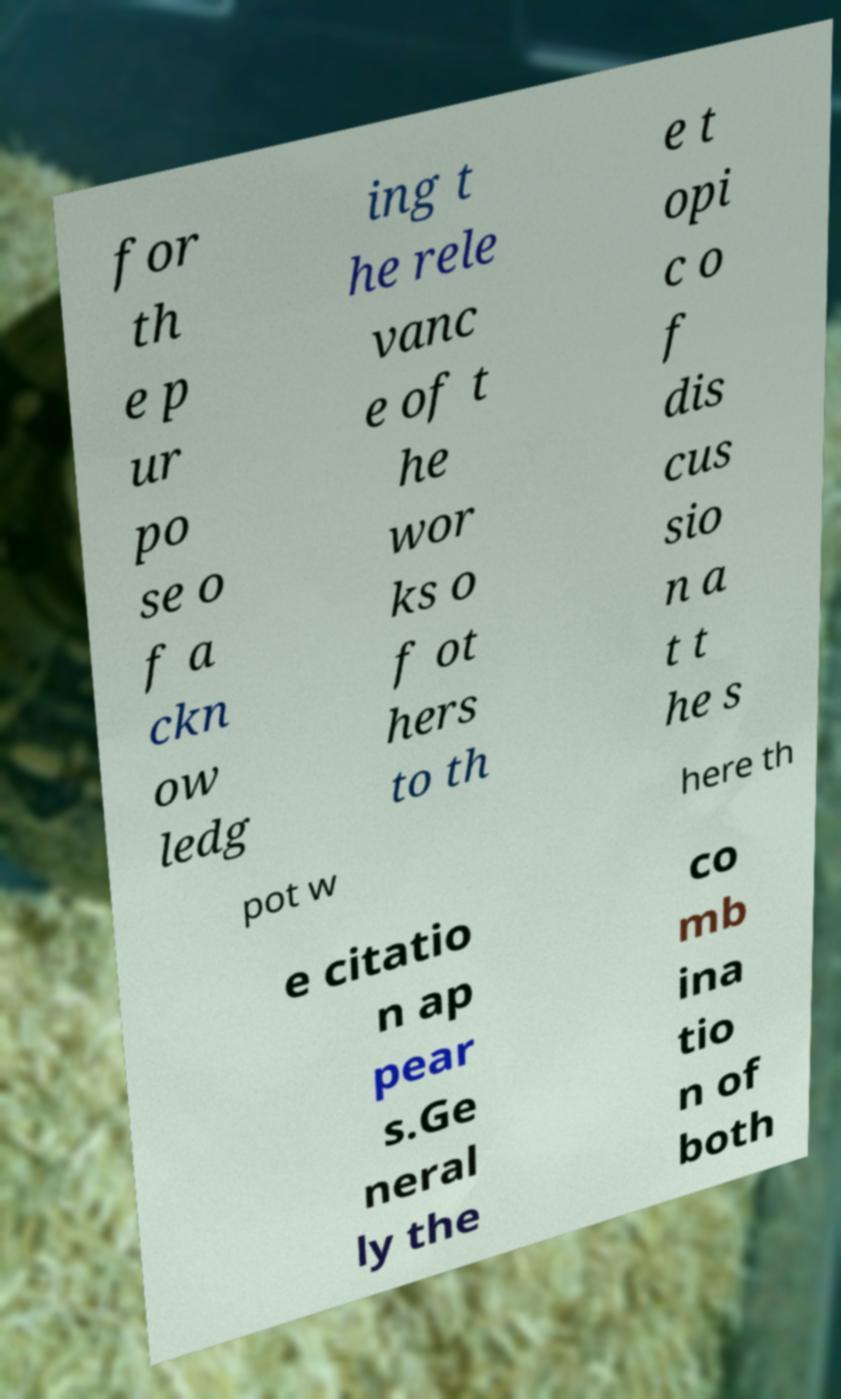Could you extract and type out the text from this image? for th e p ur po se o f a ckn ow ledg ing t he rele vanc e of t he wor ks o f ot hers to th e t opi c o f dis cus sio n a t t he s pot w here th e citatio n ap pear s.Ge neral ly the co mb ina tio n of both 